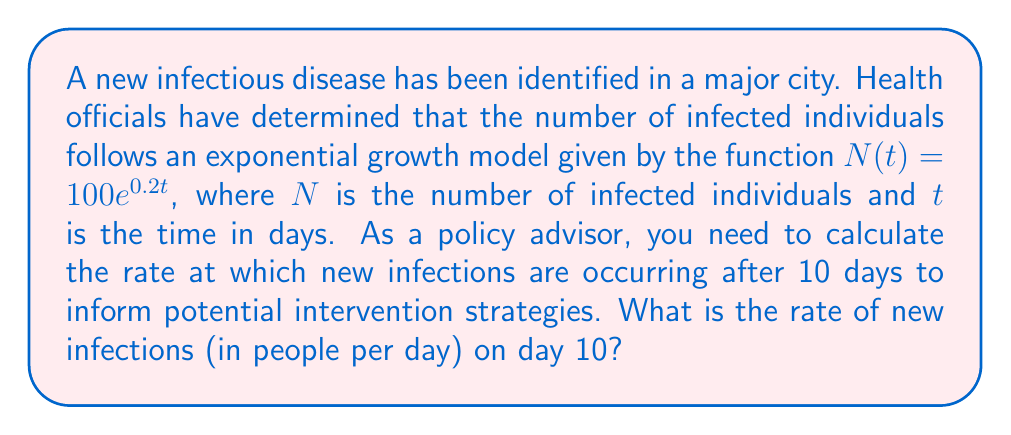Can you solve this math problem? To solve this problem, we'll follow these steps:

1) The exponential growth model is given by $N(t) = 100e^{0.2t}$

2) To find the rate of new infections, we need to calculate the derivative of this function with respect to time:

   $\frac{dN}{dt} = 100 \cdot 0.2e^{0.2t} = 20e^{0.2t}$

3) This derivative represents the rate of change of the number of infected individuals with respect to time, i.e., the number of new infections per day.

4) To find the rate on day 10, we substitute $t = 10$ into this derivative:

   $\frac{dN}{dt}|_{t=10} = 20e^{0.2(10)} = 20e^2$

5) Calculate the value:
   $20e^2 \approx 20 \cdot 7.389 \approx 147.78$

Therefore, on day 10, new infections are occurring at a rate of approximately 148 people per day.
Answer: 148 people per day 